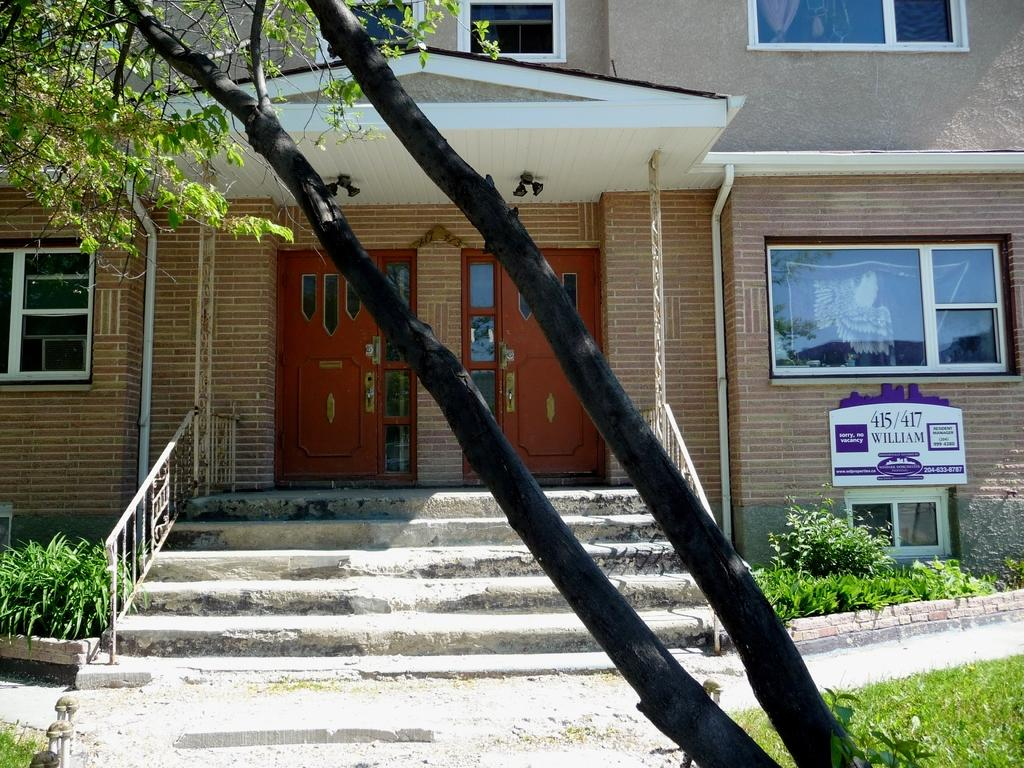What type of natural elements can be seen in the image? There are trees and plants in the image. What architectural features are present in the image? There are steps, an iron fence, and a building in the image. Can you describe the building in the image? The building has windows, a board, and doors. Reasoning: Let's think step by step by step in order to produce the conversation. We start by identifying the natural elements in the image, which are the trees and plants. Then, we move on to the architectural features, such as the steps, iron fence, and building. Finally, we provide a more detailed description of the building, mentioning its windows, board, and doors. Absurd Question/Answer: How many geese are walking on the steps in the image? There are no geese present in the image; it features trees, plants, steps, an iron fence, and a building. What is the girl doing in the image? There is no girl present in the image. How many trucks are parked near the building in the image? There are no trucks present in the image; it features trees, plants, steps, an iron fence, and a building. 